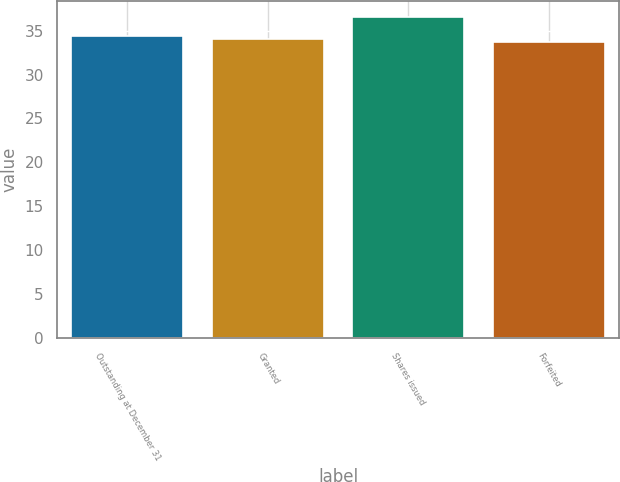<chart> <loc_0><loc_0><loc_500><loc_500><bar_chart><fcel>Outstanding at December 31<fcel>Granted<fcel>Shares issued<fcel>Forfeited<nl><fcel>34.4<fcel>34.05<fcel>36.57<fcel>33.7<nl></chart> 